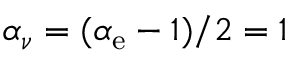<formula> <loc_0><loc_0><loc_500><loc_500>\alpha _ { \nu } = ( \alpha _ { e } - 1 ) / 2 = 1</formula> 